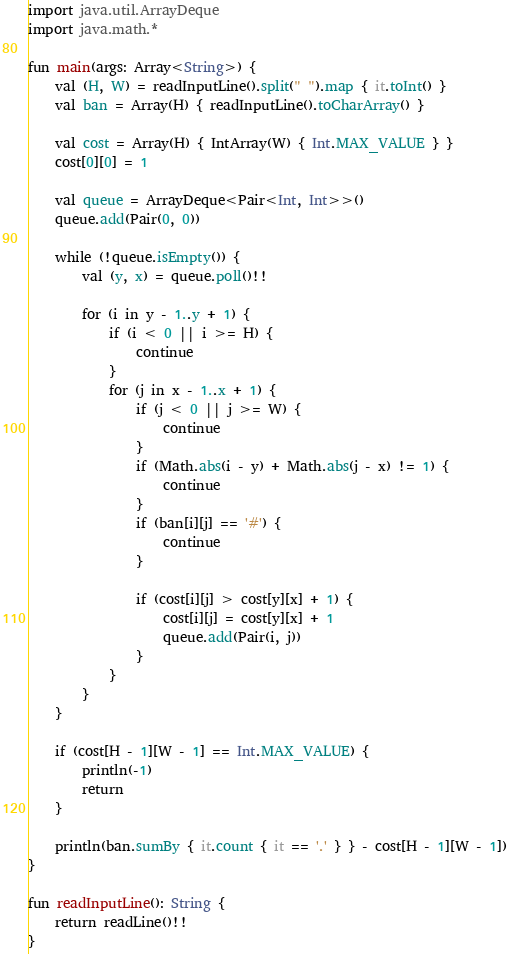Convert code to text. <code><loc_0><loc_0><loc_500><loc_500><_Kotlin_>import java.util.ArrayDeque
import java.math.*

fun main(args: Array<String>) {
    val (H, W) = readInputLine().split(" ").map { it.toInt() }
    val ban = Array(H) { readInputLine().toCharArray() }
    
    val cost = Array(H) { IntArray(W) { Int.MAX_VALUE } }
    cost[0][0] = 1
    
    val queue = ArrayDeque<Pair<Int, Int>>()
    queue.add(Pair(0, 0))

    while (!queue.isEmpty()) {
        val (y, x) = queue.poll()!!
        
        for (i in y - 1..y + 1) {
            if (i < 0 || i >= H) {
                continue
            }
            for (j in x - 1..x + 1) {
                if (j < 0 || j >= W) {
                    continue
                }
                if (Math.abs(i - y) + Math.abs(j - x) != 1) {
                    continue
                }
                if (ban[i][j] == '#') {
                    continue
                }
                
                if (cost[i][j] > cost[y][x] + 1) {
                    cost[i][j] = cost[y][x] + 1
                    queue.add(Pair(i, j))
                }
            }
        }
    }
    
    if (cost[H - 1][W - 1] == Int.MAX_VALUE) {
        println(-1)
        return
    }

    println(ban.sumBy { it.count { it == '.' } } - cost[H - 1][W - 1])
}

fun readInputLine(): String {
    return readLine()!!
}
</code> 